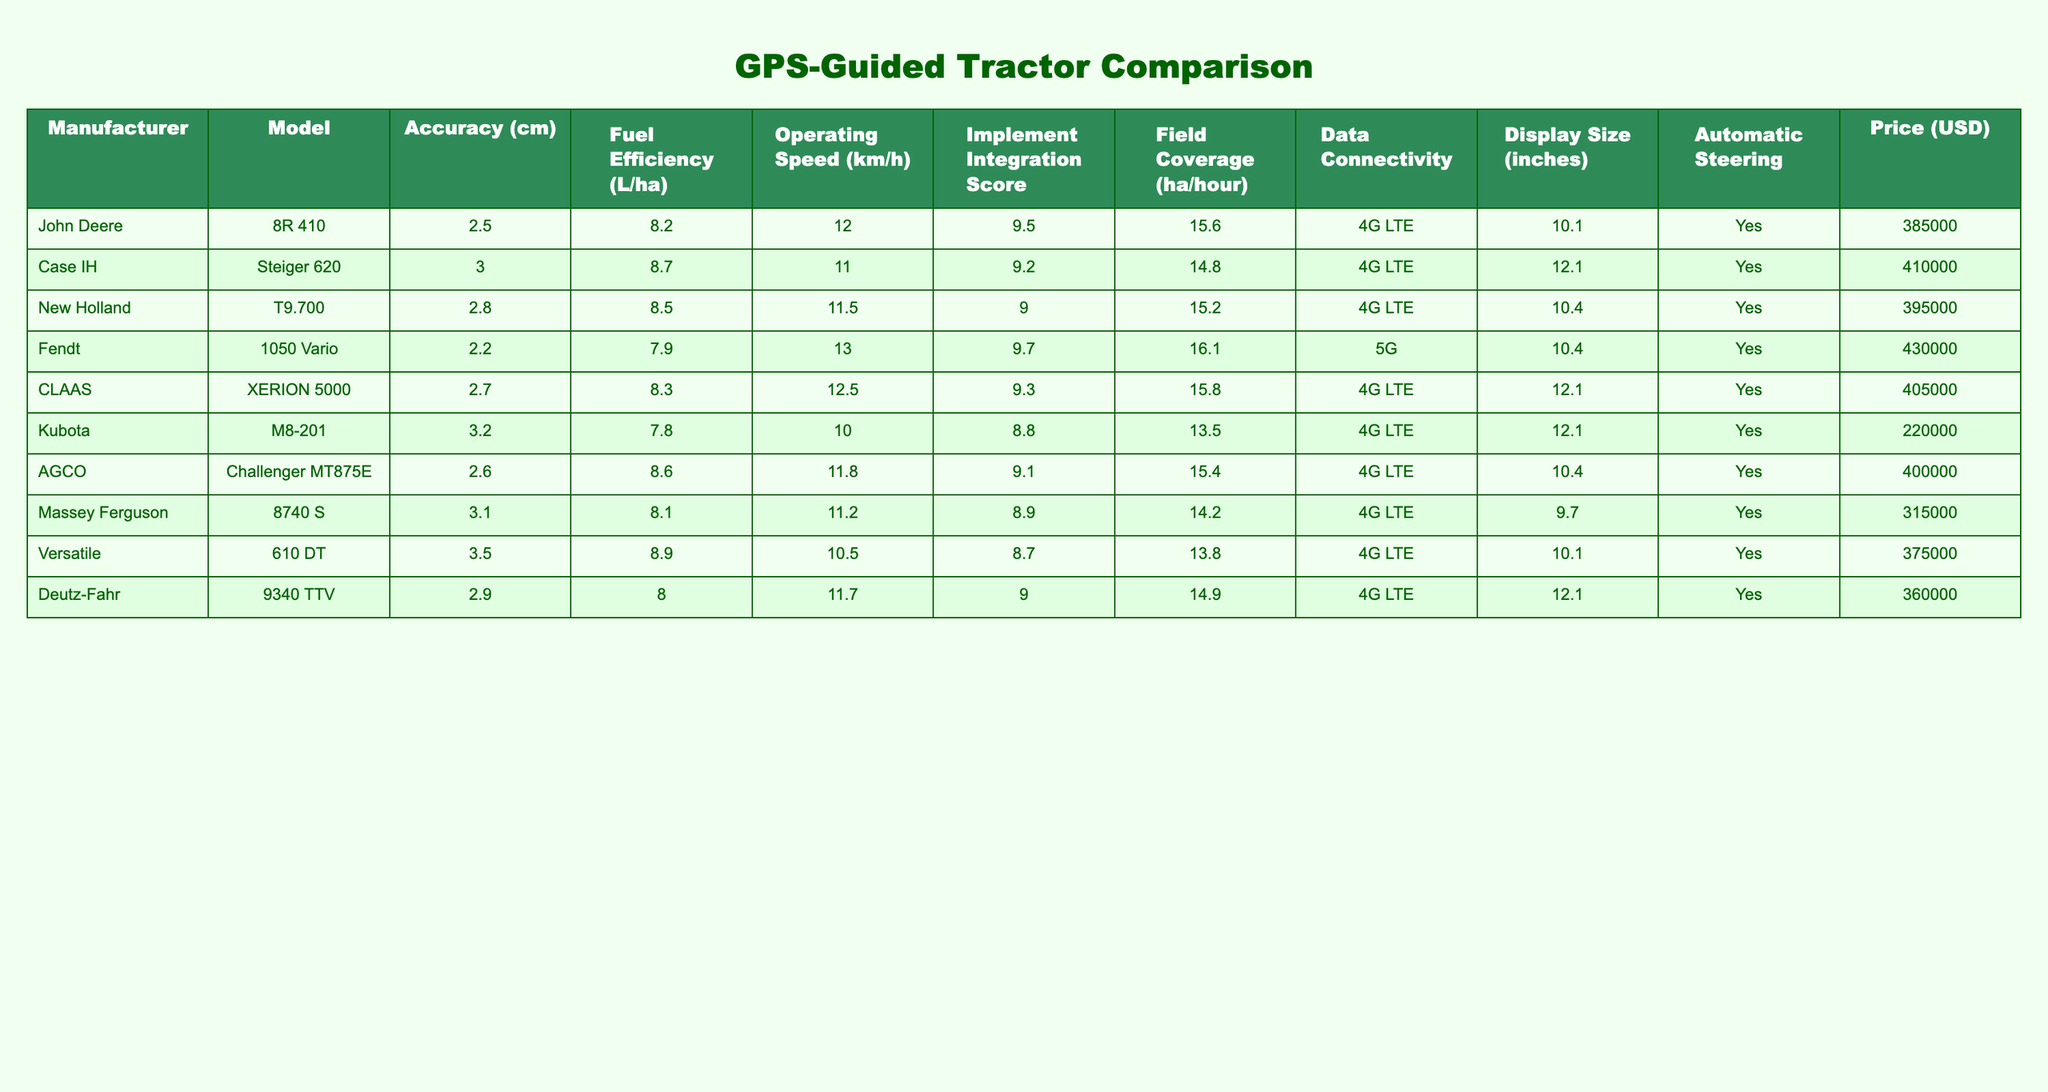What is the accuracy of Fendt 1050 Vario? The table shows that the accuracy value for the Fendt 1050 Vario model is listed as 2.2 cm.
Answer: 2.2 cm Which manufacturer has the highest operating speed? By reviewing the 'Operating Speed' column, we see the Fendt 1050 Vario has the highest value of 13 km/h, compared to other manufacturers.
Answer: Fendt What is the price difference between the most expensive and the least expensive tractor? The most expensive tractor is the Case IH Steiger 620 at 410000 USD, while the least expensive is the Kubota M8-201 at 220000 USD. The price difference is calculated as 410000 - 220000 = 190000 USD.
Answer: 190000 USD Is the John Deere 8R 410 model equipped with automatic steering? The table indicates that the 'Automatic Steering' column for the John Deere 8R 410 model is marked as 'Yes'.
Answer: Yes What is the average fuel efficiency of tractors from Case IH, New Holland, and AGCO? The fuel efficiency values for these models are: Case IH Steiger 620 - 8.7 L/ha, New Holland T9.700 - 8.5 L/ha, and AGCO Challenger MT875E - 8.6 L/ha. The average can be calculated as (8.7 + 8.5 + 8.6) / 3 = 8.6 L/ha.
Answer: 8.6 L/ha Which model has the best score in Implement Integration? The model with the highest Implement Integration Score is the Fendt 1050 Vario with a score of 9.7, indicating it excels in integrating various implements.
Answer: Fendt 1050 Vario How many tractors have a fuel efficiency of less than 8.0 L/ha? By examining the 'Fuel Efficiency' column, only the Kubota M8-201 (7.8 L/ha) falls below 8.0 L/ha, indicating that just one tractor has this efficiency.
Answer: 1 What is the field coverage per hour for the Case IH Steiger 620? According to the table, the field coverage for the Case IH Steiger 620 is 14.8 ha/hour.
Answer: 14.8 ha/hour Is there a tractor with 5G data connectivity? The data shows that only the Fendt 1050 Vario has a data connectivity option marked as '5G', while others are listed as '4G LTE'.
Answer: Yes 